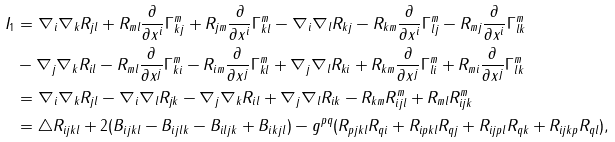<formula> <loc_0><loc_0><loc_500><loc_500>I _ { 1 } & = \nabla _ { i } \nabla _ { k } R _ { j l } + R _ { m l } \frac { \partial } { \partial x ^ { i } } \Gamma ^ { m } _ { k j } + R _ { j m } \frac { \partial } { \partial x ^ { i } } \Gamma ^ { m } _ { k l } - \nabla _ { i } \nabla _ { l } R _ { k j } - R _ { k m } \frac { \partial } { \partial x ^ { i } } \Gamma ^ { m } _ { l j } - R _ { m j } \frac { \partial } { \partial x ^ { i } } \Gamma ^ { m } _ { l k } \\ & - \nabla _ { j } \nabla _ { k } R _ { i l } - R _ { m l } \frac { \partial } { \partial x ^ { j } } \Gamma ^ { m } _ { k i } - R _ { i m } \frac { \partial } { \partial x ^ { j } } \Gamma ^ { m } _ { k l } + \nabla _ { j } \nabla _ { l } R _ { k i } + R _ { k m } \frac { \partial } { \partial x ^ { j } } \Gamma ^ { m } _ { l i } + R _ { m i } \frac { \partial } { \partial x ^ { j } } \Gamma ^ { m } _ { l k } \\ & = \nabla _ { i } \nabla _ { k } R _ { j l } - \nabla _ { i } \nabla _ { l } R _ { j k } - \nabla _ { j } \nabla _ { k } R _ { i l } + \nabla _ { j } \nabla _ { l } R _ { i k } - R _ { k m } R ^ { m } _ { i j l } + R _ { m l } R _ { i j k } ^ { m } \\ & = \triangle R _ { i j k l } + 2 ( B _ { i j k l } - B _ { i j l k } - B _ { i l j k } + B _ { i k j l } ) - g ^ { p q } ( R _ { p j k l } R _ { q i } + R _ { i p k l } R _ { q j } + R _ { i j p l } R _ { q k } + R _ { i j k p } R _ { q l } ) , \\</formula> 